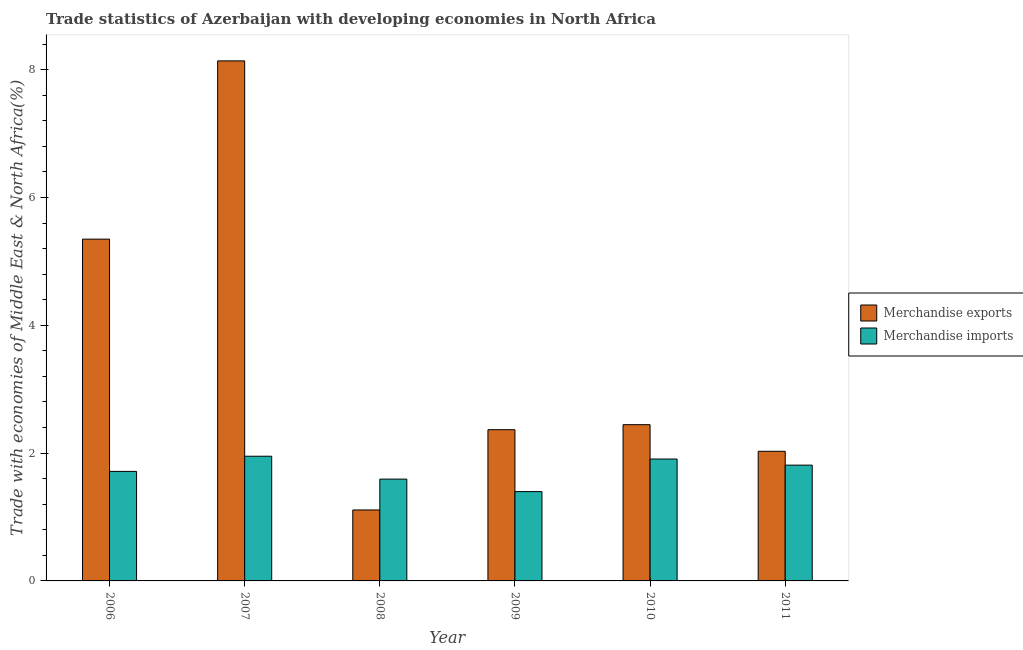How many different coloured bars are there?
Your response must be concise. 2. How many groups of bars are there?
Give a very brief answer. 6. Are the number of bars on each tick of the X-axis equal?
Make the answer very short. Yes. How many bars are there on the 4th tick from the left?
Keep it short and to the point. 2. How many bars are there on the 2nd tick from the right?
Your answer should be very brief. 2. What is the label of the 5th group of bars from the left?
Keep it short and to the point. 2010. What is the merchandise imports in 2009?
Ensure brevity in your answer.  1.4. Across all years, what is the maximum merchandise imports?
Offer a very short reply. 1.95. Across all years, what is the minimum merchandise exports?
Offer a terse response. 1.11. In which year was the merchandise exports maximum?
Make the answer very short. 2007. What is the total merchandise exports in the graph?
Offer a very short reply. 21.44. What is the difference between the merchandise imports in 2006 and that in 2010?
Your response must be concise. -0.19. What is the difference between the merchandise imports in 2011 and the merchandise exports in 2009?
Provide a short and direct response. 0.41. What is the average merchandise imports per year?
Keep it short and to the point. 1.73. In the year 2007, what is the difference between the merchandise imports and merchandise exports?
Your answer should be compact. 0. In how many years, is the merchandise imports greater than 6.8 %?
Your response must be concise. 0. What is the ratio of the merchandise imports in 2008 to that in 2009?
Provide a succinct answer. 1.14. Is the merchandise imports in 2007 less than that in 2010?
Keep it short and to the point. No. What is the difference between the highest and the second highest merchandise imports?
Offer a very short reply. 0.04. What is the difference between the highest and the lowest merchandise exports?
Ensure brevity in your answer.  7.03. Is the sum of the merchandise exports in 2006 and 2011 greater than the maximum merchandise imports across all years?
Ensure brevity in your answer.  No. What does the 2nd bar from the left in 2008 represents?
Provide a short and direct response. Merchandise imports. How many bars are there?
Give a very brief answer. 12. Are all the bars in the graph horizontal?
Make the answer very short. No. How many years are there in the graph?
Your answer should be compact. 6. Are the values on the major ticks of Y-axis written in scientific E-notation?
Provide a succinct answer. No. Does the graph contain any zero values?
Your response must be concise. No. Does the graph contain grids?
Give a very brief answer. No. How many legend labels are there?
Provide a succinct answer. 2. What is the title of the graph?
Your response must be concise. Trade statistics of Azerbaijan with developing economies in North Africa. What is the label or title of the Y-axis?
Your answer should be compact. Trade with economies of Middle East & North Africa(%). What is the Trade with economies of Middle East & North Africa(%) of Merchandise exports in 2006?
Make the answer very short. 5.35. What is the Trade with economies of Middle East & North Africa(%) in Merchandise imports in 2006?
Provide a succinct answer. 1.71. What is the Trade with economies of Middle East & North Africa(%) in Merchandise exports in 2007?
Your answer should be compact. 8.14. What is the Trade with economies of Middle East & North Africa(%) in Merchandise imports in 2007?
Provide a succinct answer. 1.95. What is the Trade with economies of Middle East & North Africa(%) of Merchandise exports in 2008?
Your response must be concise. 1.11. What is the Trade with economies of Middle East & North Africa(%) in Merchandise imports in 2008?
Provide a short and direct response. 1.59. What is the Trade with economies of Middle East & North Africa(%) of Merchandise exports in 2009?
Offer a very short reply. 2.37. What is the Trade with economies of Middle East & North Africa(%) of Merchandise imports in 2009?
Keep it short and to the point. 1.4. What is the Trade with economies of Middle East & North Africa(%) of Merchandise exports in 2010?
Ensure brevity in your answer.  2.44. What is the Trade with economies of Middle East & North Africa(%) in Merchandise imports in 2010?
Keep it short and to the point. 1.91. What is the Trade with economies of Middle East & North Africa(%) in Merchandise exports in 2011?
Your response must be concise. 2.03. What is the Trade with economies of Middle East & North Africa(%) in Merchandise imports in 2011?
Ensure brevity in your answer.  1.81. Across all years, what is the maximum Trade with economies of Middle East & North Africa(%) in Merchandise exports?
Give a very brief answer. 8.14. Across all years, what is the maximum Trade with economies of Middle East & North Africa(%) of Merchandise imports?
Provide a short and direct response. 1.95. Across all years, what is the minimum Trade with economies of Middle East & North Africa(%) of Merchandise exports?
Your answer should be compact. 1.11. Across all years, what is the minimum Trade with economies of Middle East & North Africa(%) in Merchandise imports?
Offer a very short reply. 1.4. What is the total Trade with economies of Middle East & North Africa(%) in Merchandise exports in the graph?
Keep it short and to the point. 21.44. What is the total Trade with economies of Middle East & North Africa(%) of Merchandise imports in the graph?
Provide a short and direct response. 10.37. What is the difference between the Trade with economies of Middle East & North Africa(%) of Merchandise exports in 2006 and that in 2007?
Give a very brief answer. -2.79. What is the difference between the Trade with economies of Middle East & North Africa(%) of Merchandise imports in 2006 and that in 2007?
Your response must be concise. -0.24. What is the difference between the Trade with economies of Middle East & North Africa(%) of Merchandise exports in 2006 and that in 2008?
Your response must be concise. 4.24. What is the difference between the Trade with economies of Middle East & North Africa(%) of Merchandise imports in 2006 and that in 2008?
Keep it short and to the point. 0.12. What is the difference between the Trade with economies of Middle East & North Africa(%) of Merchandise exports in 2006 and that in 2009?
Ensure brevity in your answer.  2.98. What is the difference between the Trade with economies of Middle East & North Africa(%) of Merchandise imports in 2006 and that in 2009?
Offer a terse response. 0.32. What is the difference between the Trade with economies of Middle East & North Africa(%) in Merchandise exports in 2006 and that in 2010?
Keep it short and to the point. 2.9. What is the difference between the Trade with economies of Middle East & North Africa(%) of Merchandise imports in 2006 and that in 2010?
Make the answer very short. -0.19. What is the difference between the Trade with economies of Middle East & North Africa(%) in Merchandise exports in 2006 and that in 2011?
Make the answer very short. 3.32. What is the difference between the Trade with economies of Middle East & North Africa(%) in Merchandise imports in 2006 and that in 2011?
Offer a very short reply. -0.1. What is the difference between the Trade with economies of Middle East & North Africa(%) in Merchandise exports in 2007 and that in 2008?
Provide a succinct answer. 7.03. What is the difference between the Trade with economies of Middle East & North Africa(%) in Merchandise imports in 2007 and that in 2008?
Your answer should be compact. 0.36. What is the difference between the Trade with economies of Middle East & North Africa(%) of Merchandise exports in 2007 and that in 2009?
Your response must be concise. 5.77. What is the difference between the Trade with economies of Middle East & North Africa(%) in Merchandise imports in 2007 and that in 2009?
Your response must be concise. 0.55. What is the difference between the Trade with economies of Middle East & North Africa(%) in Merchandise exports in 2007 and that in 2010?
Provide a succinct answer. 5.69. What is the difference between the Trade with economies of Middle East & North Africa(%) in Merchandise imports in 2007 and that in 2010?
Keep it short and to the point. 0.04. What is the difference between the Trade with economies of Middle East & North Africa(%) in Merchandise exports in 2007 and that in 2011?
Keep it short and to the point. 6.11. What is the difference between the Trade with economies of Middle East & North Africa(%) of Merchandise imports in 2007 and that in 2011?
Your answer should be very brief. 0.14. What is the difference between the Trade with economies of Middle East & North Africa(%) in Merchandise exports in 2008 and that in 2009?
Your response must be concise. -1.26. What is the difference between the Trade with economies of Middle East & North Africa(%) in Merchandise imports in 2008 and that in 2009?
Offer a terse response. 0.2. What is the difference between the Trade with economies of Middle East & North Africa(%) of Merchandise exports in 2008 and that in 2010?
Provide a short and direct response. -1.33. What is the difference between the Trade with economies of Middle East & North Africa(%) of Merchandise imports in 2008 and that in 2010?
Ensure brevity in your answer.  -0.31. What is the difference between the Trade with economies of Middle East & North Africa(%) of Merchandise exports in 2008 and that in 2011?
Ensure brevity in your answer.  -0.92. What is the difference between the Trade with economies of Middle East & North Africa(%) of Merchandise imports in 2008 and that in 2011?
Make the answer very short. -0.22. What is the difference between the Trade with economies of Middle East & North Africa(%) of Merchandise exports in 2009 and that in 2010?
Your response must be concise. -0.08. What is the difference between the Trade with economies of Middle East & North Africa(%) in Merchandise imports in 2009 and that in 2010?
Your answer should be very brief. -0.51. What is the difference between the Trade with economies of Middle East & North Africa(%) of Merchandise exports in 2009 and that in 2011?
Provide a short and direct response. 0.34. What is the difference between the Trade with economies of Middle East & North Africa(%) of Merchandise imports in 2009 and that in 2011?
Your response must be concise. -0.41. What is the difference between the Trade with economies of Middle East & North Africa(%) in Merchandise exports in 2010 and that in 2011?
Make the answer very short. 0.42. What is the difference between the Trade with economies of Middle East & North Africa(%) of Merchandise imports in 2010 and that in 2011?
Give a very brief answer. 0.1. What is the difference between the Trade with economies of Middle East & North Africa(%) in Merchandise exports in 2006 and the Trade with economies of Middle East & North Africa(%) in Merchandise imports in 2007?
Make the answer very short. 3.4. What is the difference between the Trade with economies of Middle East & North Africa(%) of Merchandise exports in 2006 and the Trade with economies of Middle East & North Africa(%) of Merchandise imports in 2008?
Provide a succinct answer. 3.76. What is the difference between the Trade with economies of Middle East & North Africa(%) of Merchandise exports in 2006 and the Trade with economies of Middle East & North Africa(%) of Merchandise imports in 2009?
Keep it short and to the point. 3.95. What is the difference between the Trade with economies of Middle East & North Africa(%) in Merchandise exports in 2006 and the Trade with economies of Middle East & North Africa(%) in Merchandise imports in 2010?
Provide a succinct answer. 3.44. What is the difference between the Trade with economies of Middle East & North Africa(%) in Merchandise exports in 2006 and the Trade with economies of Middle East & North Africa(%) in Merchandise imports in 2011?
Your response must be concise. 3.54. What is the difference between the Trade with economies of Middle East & North Africa(%) in Merchandise exports in 2007 and the Trade with economies of Middle East & North Africa(%) in Merchandise imports in 2008?
Offer a terse response. 6.54. What is the difference between the Trade with economies of Middle East & North Africa(%) of Merchandise exports in 2007 and the Trade with economies of Middle East & North Africa(%) of Merchandise imports in 2009?
Provide a short and direct response. 6.74. What is the difference between the Trade with economies of Middle East & North Africa(%) in Merchandise exports in 2007 and the Trade with economies of Middle East & North Africa(%) in Merchandise imports in 2010?
Your answer should be very brief. 6.23. What is the difference between the Trade with economies of Middle East & North Africa(%) in Merchandise exports in 2007 and the Trade with economies of Middle East & North Africa(%) in Merchandise imports in 2011?
Make the answer very short. 6.33. What is the difference between the Trade with economies of Middle East & North Africa(%) in Merchandise exports in 2008 and the Trade with economies of Middle East & North Africa(%) in Merchandise imports in 2009?
Provide a short and direct response. -0.29. What is the difference between the Trade with economies of Middle East & North Africa(%) in Merchandise exports in 2008 and the Trade with economies of Middle East & North Africa(%) in Merchandise imports in 2010?
Your answer should be compact. -0.8. What is the difference between the Trade with economies of Middle East & North Africa(%) in Merchandise exports in 2008 and the Trade with economies of Middle East & North Africa(%) in Merchandise imports in 2011?
Offer a terse response. -0.7. What is the difference between the Trade with economies of Middle East & North Africa(%) of Merchandise exports in 2009 and the Trade with economies of Middle East & North Africa(%) of Merchandise imports in 2010?
Offer a very short reply. 0.46. What is the difference between the Trade with economies of Middle East & North Africa(%) in Merchandise exports in 2009 and the Trade with economies of Middle East & North Africa(%) in Merchandise imports in 2011?
Keep it short and to the point. 0.55. What is the difference between the Trade with economies of Middle East & North Africa(%) of Merchandise exports in 2010 and the Trade with economies of Middle East & North Africa(%) of Merchandise imports in 2011?
Give a very brief answer. 0.63. What is the average Trade with economies of Middle East & North Africa(%) of Merchandise exports per year?
Keep it short and to the point. 3.57. What is the average Trade with economies of Middle East & North Africa(%) of Merchandise imports per year?
Your answer should be compact. 1.73. In the year 2006, what is the difference between the Trade with economies of Middle East & North Africa(%) of Merchandise exports and Trade with economies of Middle East & North Africa(%) of Merchandise imports?
Your response must be concise. 3.63. In the year 2007, what is the difference between the Trade with economies of Middle East & North Africa(%) of Merchandise exports and Trade with economies of Middle East & North Africa(%) of Merchandise imports?
Your answer should be compact. 6.19. In the year 2008, what is the difference between the Trade with economies of Middle East & North Africa(%) of Merchandise exports and Trade with economies of Middle East & North Africa(%) of Merchandise imports?
Ensure brevity in your answer.  -0.48. In the year 2009, what is the difference between the Trade with economies of Middle East & North Africa(%) of Merchandise exports and Trade with economies of Middle East & North Africa(%) of Merchandise imports?
Offer a terse response. 0.97. In the year 2010, what is the difference between the Trade with economies of Middle East & North Africa(%) in Merchandise exports and Trade with economies of Middle East & North Africa(%) in Merchandise imports?
Make the answer very short. 0.54. In the year 2011, what is the difference between the Trade with economies of Middle East & North Africa(%) of Merchandise exports and Trade with economies of Middle East & North Africa(%) of Merchandise imports?
Provide a succinct answer. 0.22. What is the ratio of the Trade with economies of Middle East & North Africa(%) in Merchandise exports in 2006 to that in 2007?
Your answer should be compact. 0.66. What is the ratio of the Trade with economies of Middle East & North Africa(%) in Merchandise imports in 2006 to that in 2007?
Ensure brevity in your answer.  0.88. What is the ratio of the Trade with economies of Middle East & North Africa(%) in Merchandise exports in 2006 to that in 2008?
Ensure brevity in your answer.  4.82. What is the ratio of the Trade with economies of Middle East & North Africa(%) of Merchandise imports in 2006 to that in 2008?
Offer a very short reply. 1.08. What is the ratio of the Trade with economies of Middle East & North Africa(%) of Merchandise exports in 2006 to that in 2009?
Provide a succinct answer. 2.26. What is the ratio of the Trade with economies of Middle East & North Africa(%) in Merchandise imports in 2006 to that in 2009?
Provide a succinct answer. 1.23. What is the ratio of the Trade with economies of Middle East & North Africa(%) in Merchandise exports in 2006 to that in 2010?
Your answer should be very brief. 2.19. What is the ratio of the Trade with economies of Middle East & North Africa(%) in Merchandise imports in 2006 to that in 2010?
Keep it short and to the point. 0.9. What is the ratio of the Trade with economies of Middle East & North Africa(%) of Merchandise exports in 2006 to that in 2011?
Give a very brief answer. 2.64. What is the ratio of the Trade with economies of Middle East & North Africa(%) in Merchandise imports in 2006 to that in 2011?
Give a very brief answer. 0.95. What is the ratio of the Trade with economies of Middle East & North Africa(%) of Merchandise exports in 2007 to that in 2008?
Make the answer very short. 7.33. What is the ratio of the Trade with economies of Middle East & North Africa(%) of Merchandise imports in 2007 to that in 2008?
Offer a very short reply. 1.22. What is the ratio of the Trade with economies of Middle East & North Africa(%) in Merchandise exports in 2007 to that in 2009?
Your answer should be very brief. 3.44. What is the ratio of the Trade with economies of Middle East & North Africa(%) in Merchandise imports in 2007 to that in 2009?
Your answer should be very brief. 1.4. What is the ratio of the Trade with economies of Middle East & North Africa(%) of Merchandise exports in 2007 to that in 2010?
Make the answer very short. 3.33. What is the ratio of the Trade with economies of Middle East & North Africa(%) of Merchandise imports in 2007 to that in 2010?
Keep it short and to the point. 1.02. What is the ratio of the Trade with economies of Middle East & North Africa(%) of Merchandise exports in 2007 to that in 2011?
Keep it short and to the point. 4.01. What is the ratio of the Trade with economies of Middle East & North Africa(%) of Merchandise exports in 2008 to that in 2009?
Offer a terse response. 0.47. What is the ratio of the Trade with economies of Middle East & North Africa(%) of Merchandise imports in 2008 to that in 2009?
Provide a short and direct response. 1.14. What is the ratio of the Trade with economies of Middle East & North Africa(%) of Merchandise exports in 2008 to that in 2010?
Provide a short and direct response. 0.45. What is the ratio of the Trade with economies of Middle East & North Africa(%) of Merchandise imports in 2008 to that in 2010?
Make the answer very short. 0.84. What is the ratio of the Trade with economies of Middle East & North Africa(%) in Merchandise exports in 2008 to that in 2011?
Your answer should be compact. 0.55. What is the ratio of the Trade with economies of Middle East & North Africa(%) in Merchandise imports in 2008 to that in 2011?
Keep it short and to the point. 0.88. What is the ratio of the Trade with economies of Middle East & North Africa(%) of Merchandise exports in 2009 to that in 2010?
Keep it short and to the point. 0.97. What is the ratio of the Trade with economies of Middle East & North Africa(%) in Merchandise imports in 2009 to that in 2010?
Ensure brevity in your answer.  0.73. What is the ratio of the Trade with economies of Middle East & North Africa(%) in Merchandise exports in 2009 to that in 2011?
Your answer should be very brief. 1.17. What is the ratio of the Trade with economies of Middle East & North Africa(%) of Merchandise imports in 2009 to that in 2011?
Your answer should be compact. 0.77. What is the ratio of the Trade with economies of Middle East & North Africa(%) in Merchandise exports in 2010 to that in 2011?
Your response must be concise. 1.21. What is the ratio of the Trade with economies of Middle East & North Africa(%) of Merchandise imports in 2010 to that in 2011?
Your answer should be compact. 1.05. What is the difference between the highest and the second highest Trade with economies of Middle East & North Africa(%) of Merchandise exports?
Your answer should be compact. 2.79. What is the difference between the highest and the second highest Trade with economies of Middle East & North Africa(%) in Merchandise imports?
Provide a short and direct response. 0.04. What is the difference between the highest and the lowest Trade with economies of Middle East & North Africa(%) of Merchandise exports?
Ensure brevity in your answer.  7.03. What is the difference between the highest and the lowest Trade with economies of Middle East & North Africa(%) in Merchandise imports?
Offer a very short reply. 0.55. 